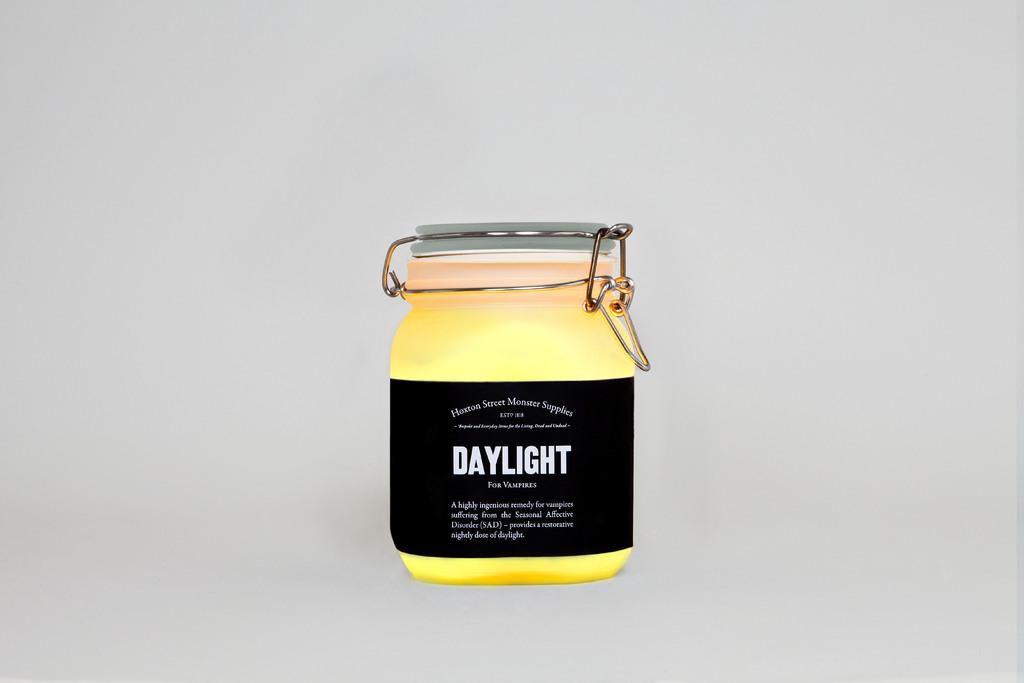Provide a one-sentence caption for the provided image. A jar with the word DAYLIGHT in big bold letters printed upon its side. 